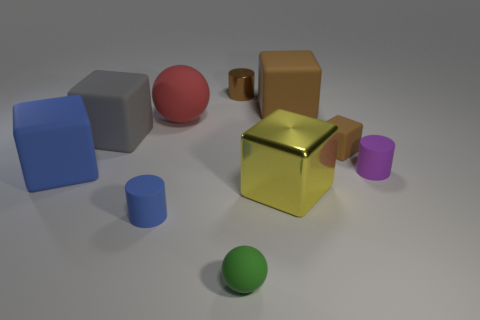Subtract all tiny brown blocks. How many blocks are left? 4 Subtract all gray blocks. How many blocks are left? 4 Subtract all green cubes. Subtract all red cylinders. How many cubes are left? 5 Subtract all cylinders. How many objects are left? 7 Subtract all large gray rubber things. Subtract all large red things. How many objects are left? 8 Add 2 yellow metallic blocks. How many yellow metallic blocks are left? 3 Add 1 red cylinders. How many red cylinders exist? 1 Subtract 1 brown blocks. How many objects are left? 9 